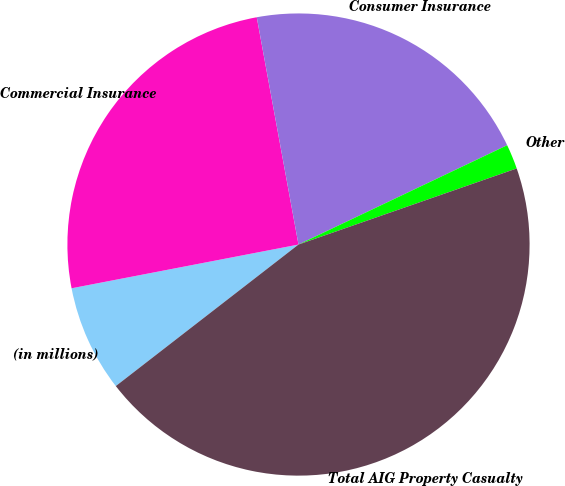<chart> <loc_0><loc_0><loc_500><loc_500><pie_chart><fcel>(in millions)<fcel>Commercial Insurance<fcel>Consumer Insurance<fcel>Other<fcel>Total AIG Property Casualty<nl><fcel>7.46%<fcel>25.14%<fcel>20.82%<fcel>1.73%<fcel>44.85%<nl></chart> 